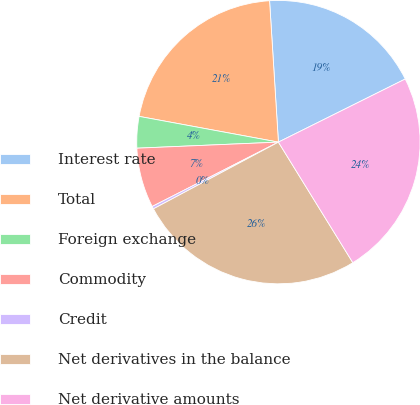<chart> <loc_0><loc_0><loc_500><loc_500><pie_chart><fcel>Interest rate<fcel>Total<fcel>Foreign exchange<fcel>Commodity<fcel>Credit<fcel>Net derivatives in the balance<fcel>Net derivative amounts<nl><fcel>18.64%<fcel>21.09%<fcel>3.59%<fcel>6.82%<fcel>0.3%<fcel>25.99%<fcel>23.54%<nl></chart> 